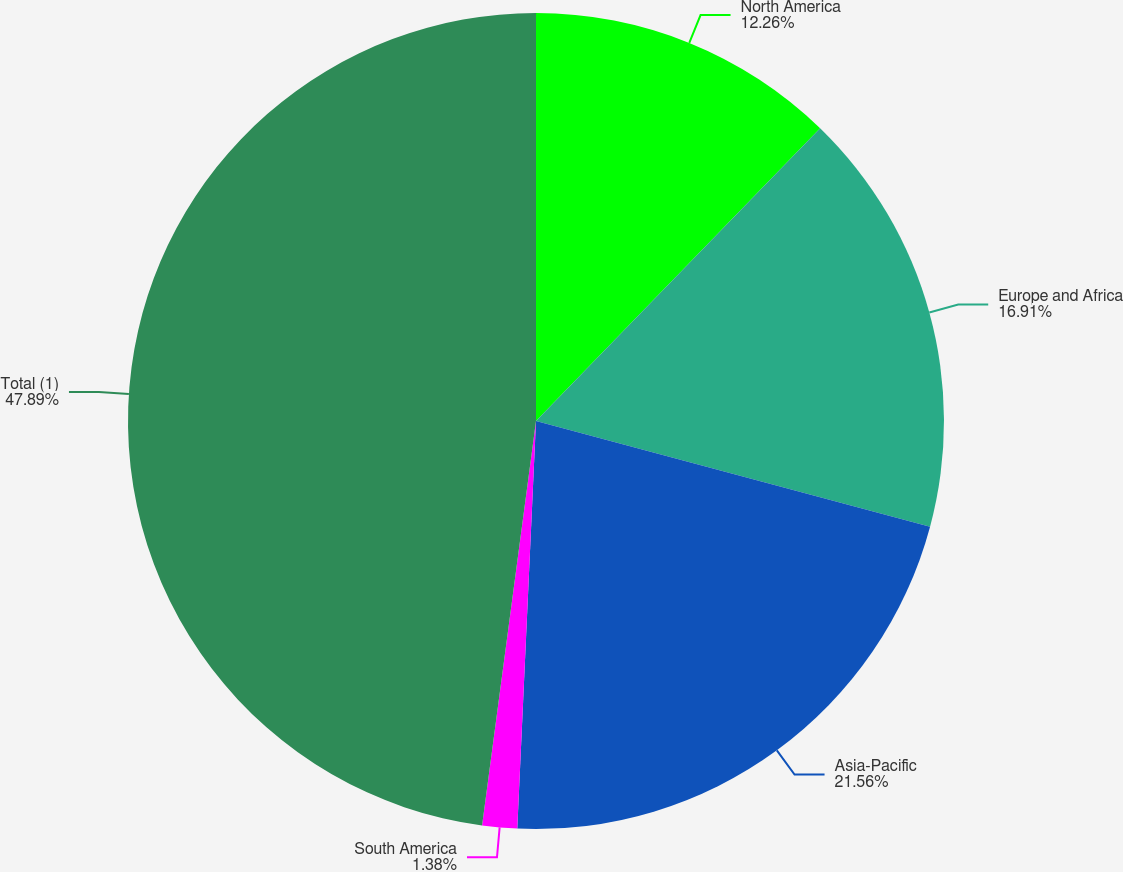Convert chart to OTSL. <chart><loc_0><loc_0><loc_500><loc_500><pie_chart><fcel>North America<fcel>Europe and Africa<fcel>Asia-Pacific<fcel>South America<fcel>Total (1)<nl><fcel>12.26%<fcel>16.91%<fcel>21.56%<fcel>1.38%<fcel>47.89%<nl></chart> 